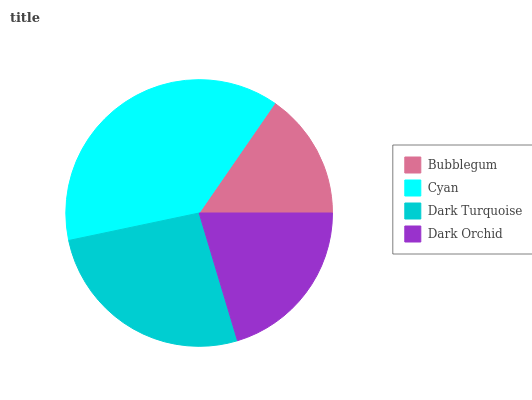Is Bubblegum the minimum?
Answer yes or no. Yes. Is Cyan the maximum?
Answer yes or no. Yes. Is Dark Turquoise the minimum?
Answer yes or no. No. Is Dark Turquoise the maximum?
Answer yes or no. No. Is Cyan greater than Dark Turquoise?
Answer yes or no. Yes. Is Dark Turquoise less than Cyan?
Answer yes or no. Yes. Is Dark Turquoise greater than Cyan?
Answer yes or no. No. Is Cyan less than Dark Turquoise?
Answer yes or no. No. Is Dark Turquoise the high median?
Answer yes or no. Yes. Is Dark Orchid the low median?
Answer yes or no. Yes. Is Cyan the high median?
Answer yes or no. No. Is Dark Turquoise the low median?
Answer yes or no. No. 